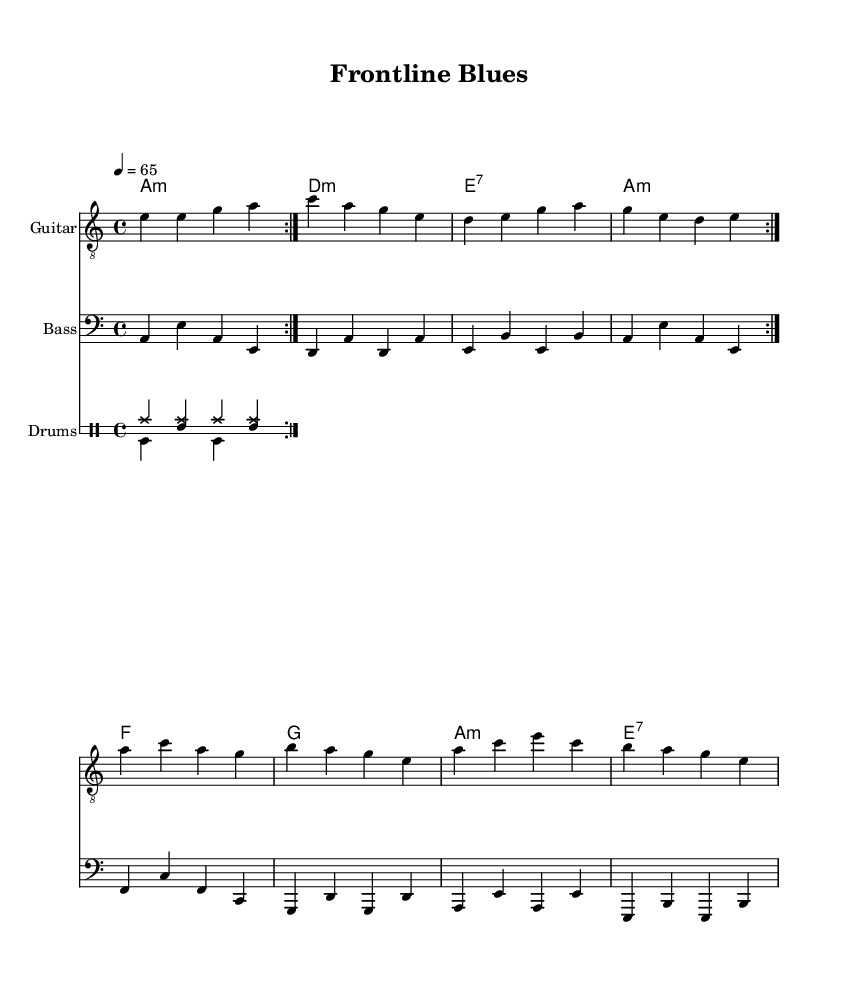What is the key signature of this music? The key signature is A minor, which has no sharps or flats; it is indicated at the beginning of the score.
Answer: A minor What is the time signature of this music? The time signature is 4/4, indicating there are four beats per measure and the quarter note gets one beat, which is seen at the beginning of the score.
Answer: 4/4 What is the tempo marking for this piece? The tempo marking is 4 equals 65, indicating that the quarter note should be played at a speed of 65 beats per minute, which can be found in the tempo section of the score.
Answer: 65 How many measures are in the guitar section? The guitar section has 10 measures total; this includes two repeats and the measures can be counted through the music.
Answer: 10 What type of chords does this piece primarily use? This piece primarily uses minor and seventh chords, as indicated by the chord symbols listed above the staff, specifically mentioning A minor, D minor, and E seventh chords.
Answer: Minor and seventh Which instruments are featured in this score? The featured instruments in this score are guitar, bass, and drums, which are indicated by the instrument names at the beginning of each staff.
Answer: Guitar, bass, drums What is the primary emotional theme expressed in this electric blues piece? The primary emotional theme expressed in this piece relates to the toll of the pandemic on medical professionals, which can be inferred from the title "Frontline Blues" and its soulful themes typical of electric blues music.
Answer: Emotional toll of the pandemic 